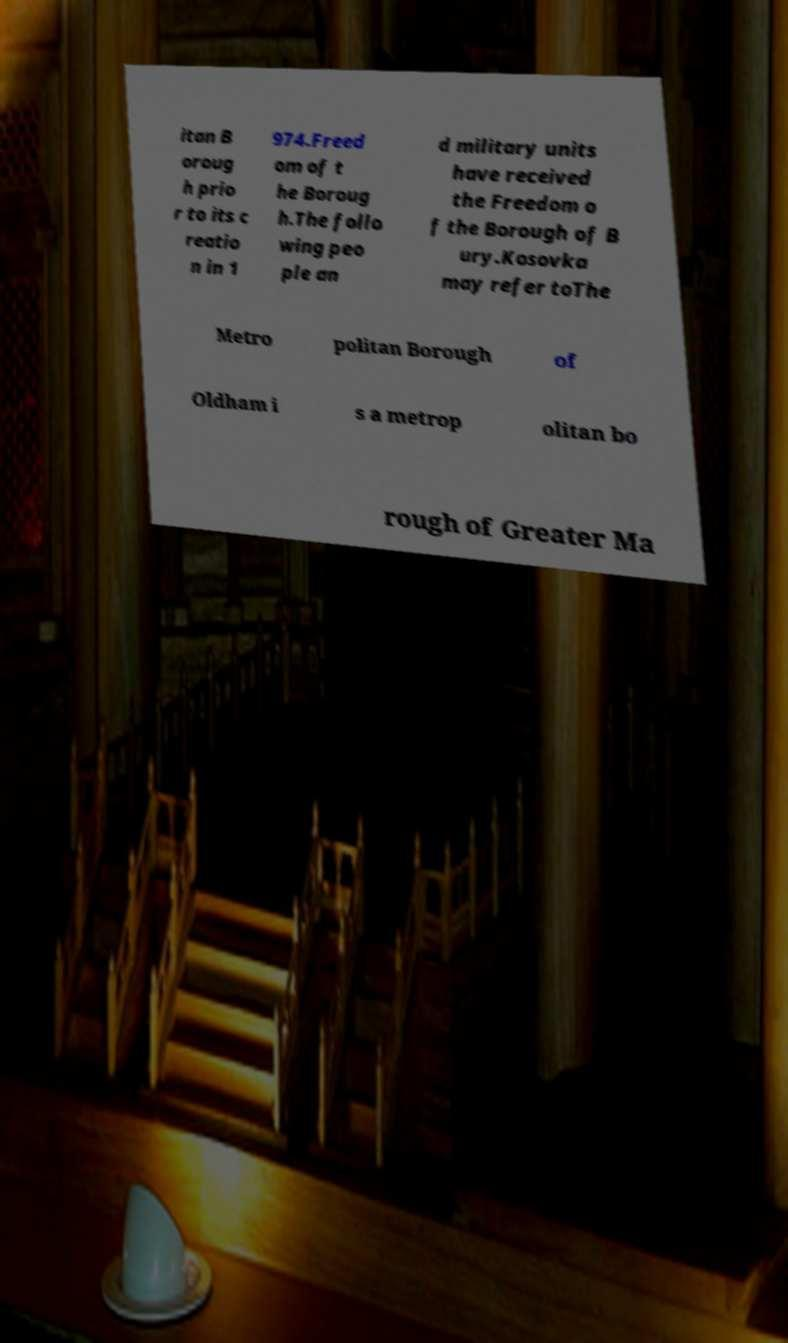Please identify and transcribe the text found in this image. itan B oroug h prio r to its c reatio n in 1 974.Freed om of t he Boroug h.The follo wing peo ple an d military units have received the Freedom o f the Borough of B ury.Kosovka may refer toThe Metro politan Borough of Oldham i s a metrop olitan bo rough of Greater Ma 